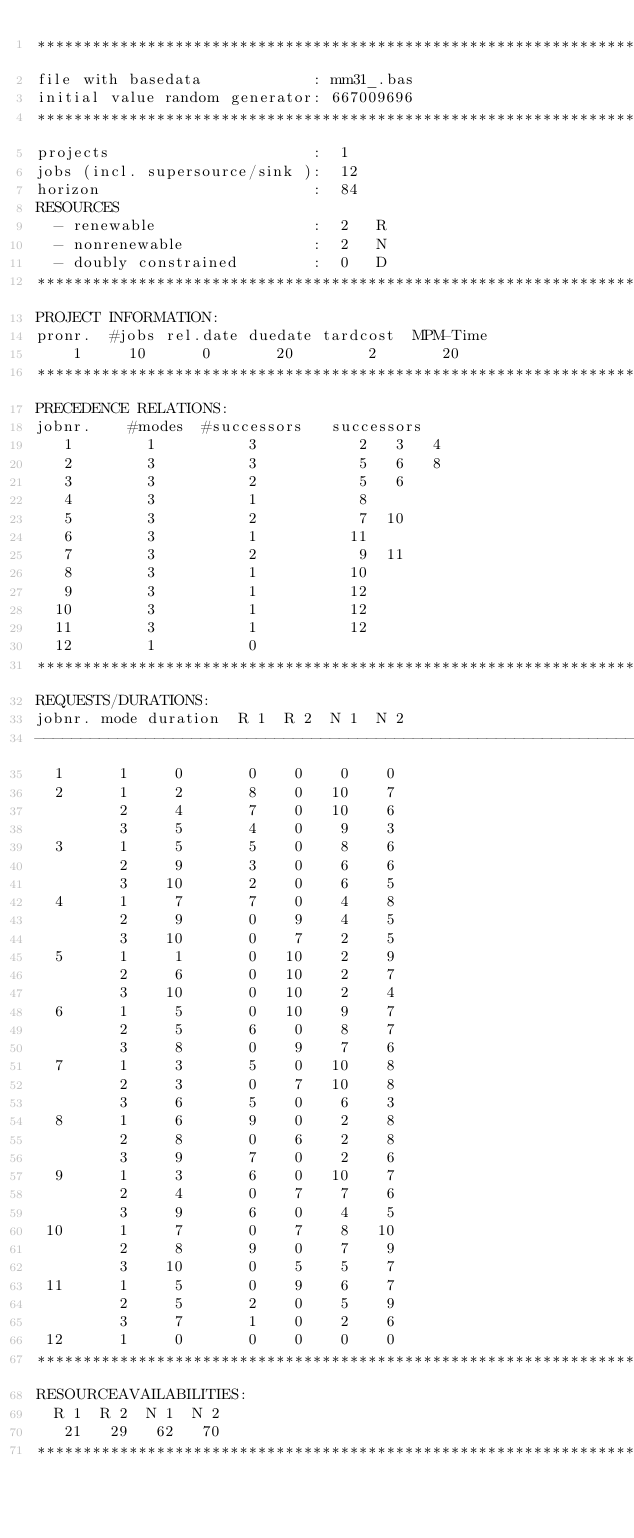<code> <loc_0><loc_0><loc_500><loc_500><_ObjectiveC_>************************************************************************
file with basedata            : mm31_.bas
initial value random generator: 667009696
************************************************************************
projects                      :  1
jobs (incl. supersource/sink ):  12
horizon                       :  84
RESOURCES
  - renewable                 :  2   R
  - nonrenewable              :  2   N
  - doubly constrained        :  0   D
************************************************************************
PROJECT INFORMATION:
pronr.  #jobs rel.date duedate tardcost  MPM-Time
    1     10      0       20        2       20
************************************************************************
PRECEDENCE RELATIONS:
jobnr.    #modes  #successors   successors
   1        1          3           2   3   4
   2        3          3           5   6   8
   3        3          2           5   6
   4        3          1           8
   5        3          2           7  10
   6        3          1          11
   7        3          2           9  11
   8        3          1          10
   9        3          1          12
  10        3          1          12
  11        3          1          12
  12        1          0        
************************************************************************
REQUESTS/DURATIONS:
jobnr. mode duration  R 1  R 2  N 1  N 2
------------------------------------------------------------------------
  1      1     0       0    0    0    0
  2      1     2       8    0   10    7
         2     4       7    0   10    6
         3     5       4    0    9    3
  3      1     5       5    0    8    6
         2     9       3    0    6    6
         3    10       2    0    6    5
  4      1     7       7    0    4    8
         2     9       0    9    4    5
         3    10       0    7    2    5
  5      1     1       0   10    2    9
         2     6       0   10    2    7
         3    10       0   10    2    4
  6      1     5       0   10    9    7
         2     5       6    0    8    7
         3     8       0    9    7    6
  7      1     3       5    0   10    8
         2     3       0    7   10    8
         3     6       5    0    6    3
  8      1     6       9    0    2    8
         2     8       0    6    2    8
         3     9       7    0    2    6
  9      1     3       6    0   10    7
         2     4       0    7    7    6
         3     9       6    0    4    5
 10      1     7       0    7    8   10
         2     8       9    0    7    9
         3    10       0    5    5    7
 11      1     5       0    9    6    7
         2     5       2    0    5    9
         3     7       1    0    2    6
 12      1     0       0    0    0    0
************************************************************************
RESOURCEAVAILABILITIES:
  R 1  R 2  N 1  N 2
   21   29   62   70
************************************************************************
</code> 